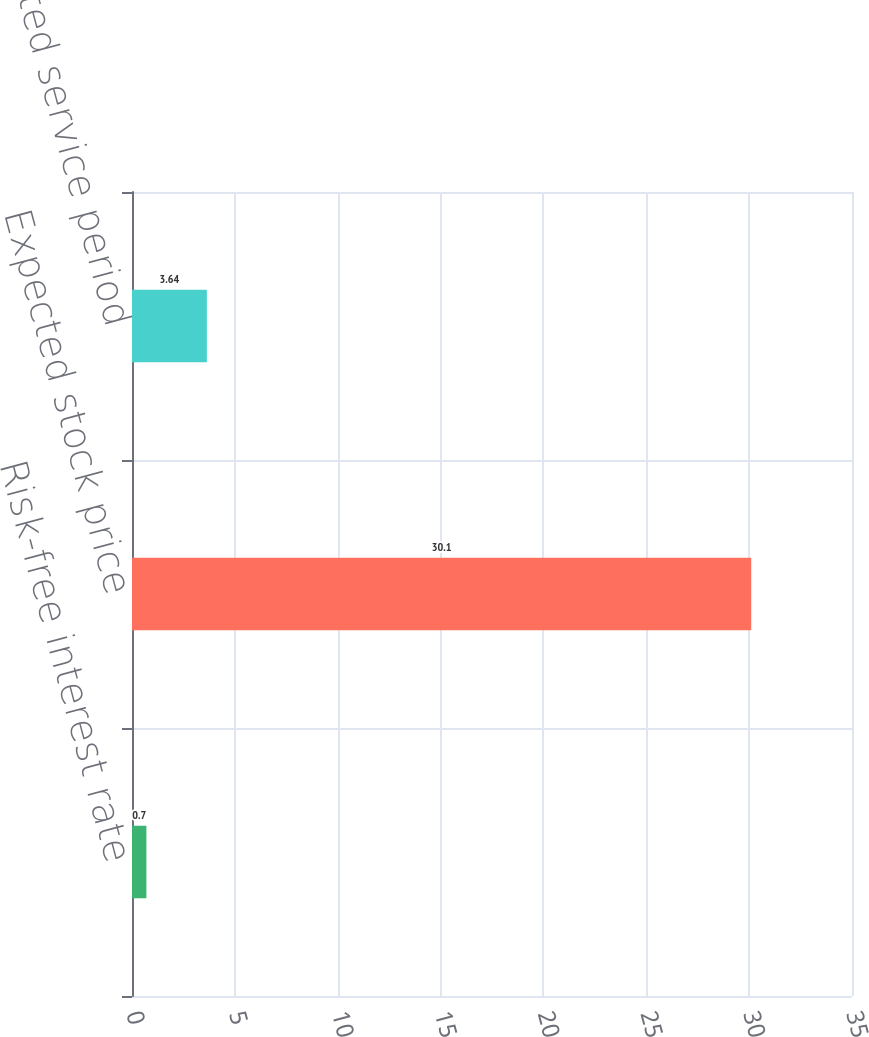Convert chart to OTSL. <chart><loc_0><loc_0><loc_500><loc_500><bar_chart><fcel>Risk-free interest rate<fcel>Expected stock price<fcel>Expected service period<nl><fcel>0.7<fcel>30.1<fcel>3.64<nl></chart> 